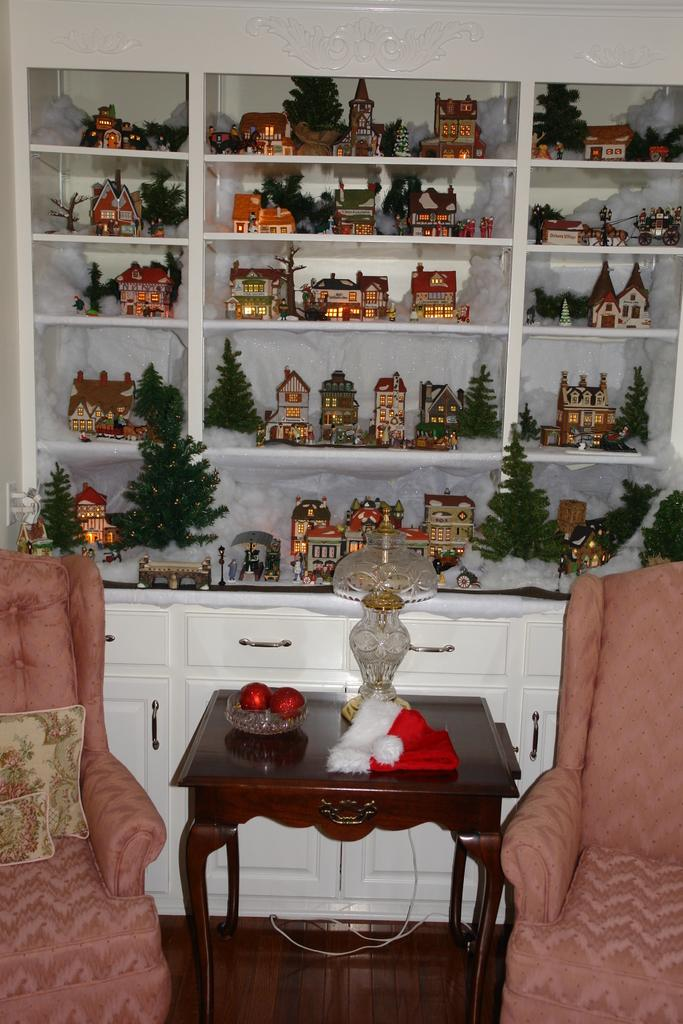Where was the image taken? The image was taken inside a room. What furniture is present in the room? There are two chairs and a table in the room. Is there any storage or display space in the room? Yes, there is a shelf in the background of the image. What can be found on the shelf? There are many objects on the shelf. What type of board game is being played on the table in the image? There is no board game visible in the image; only the chairs, table, and shelf are present. 